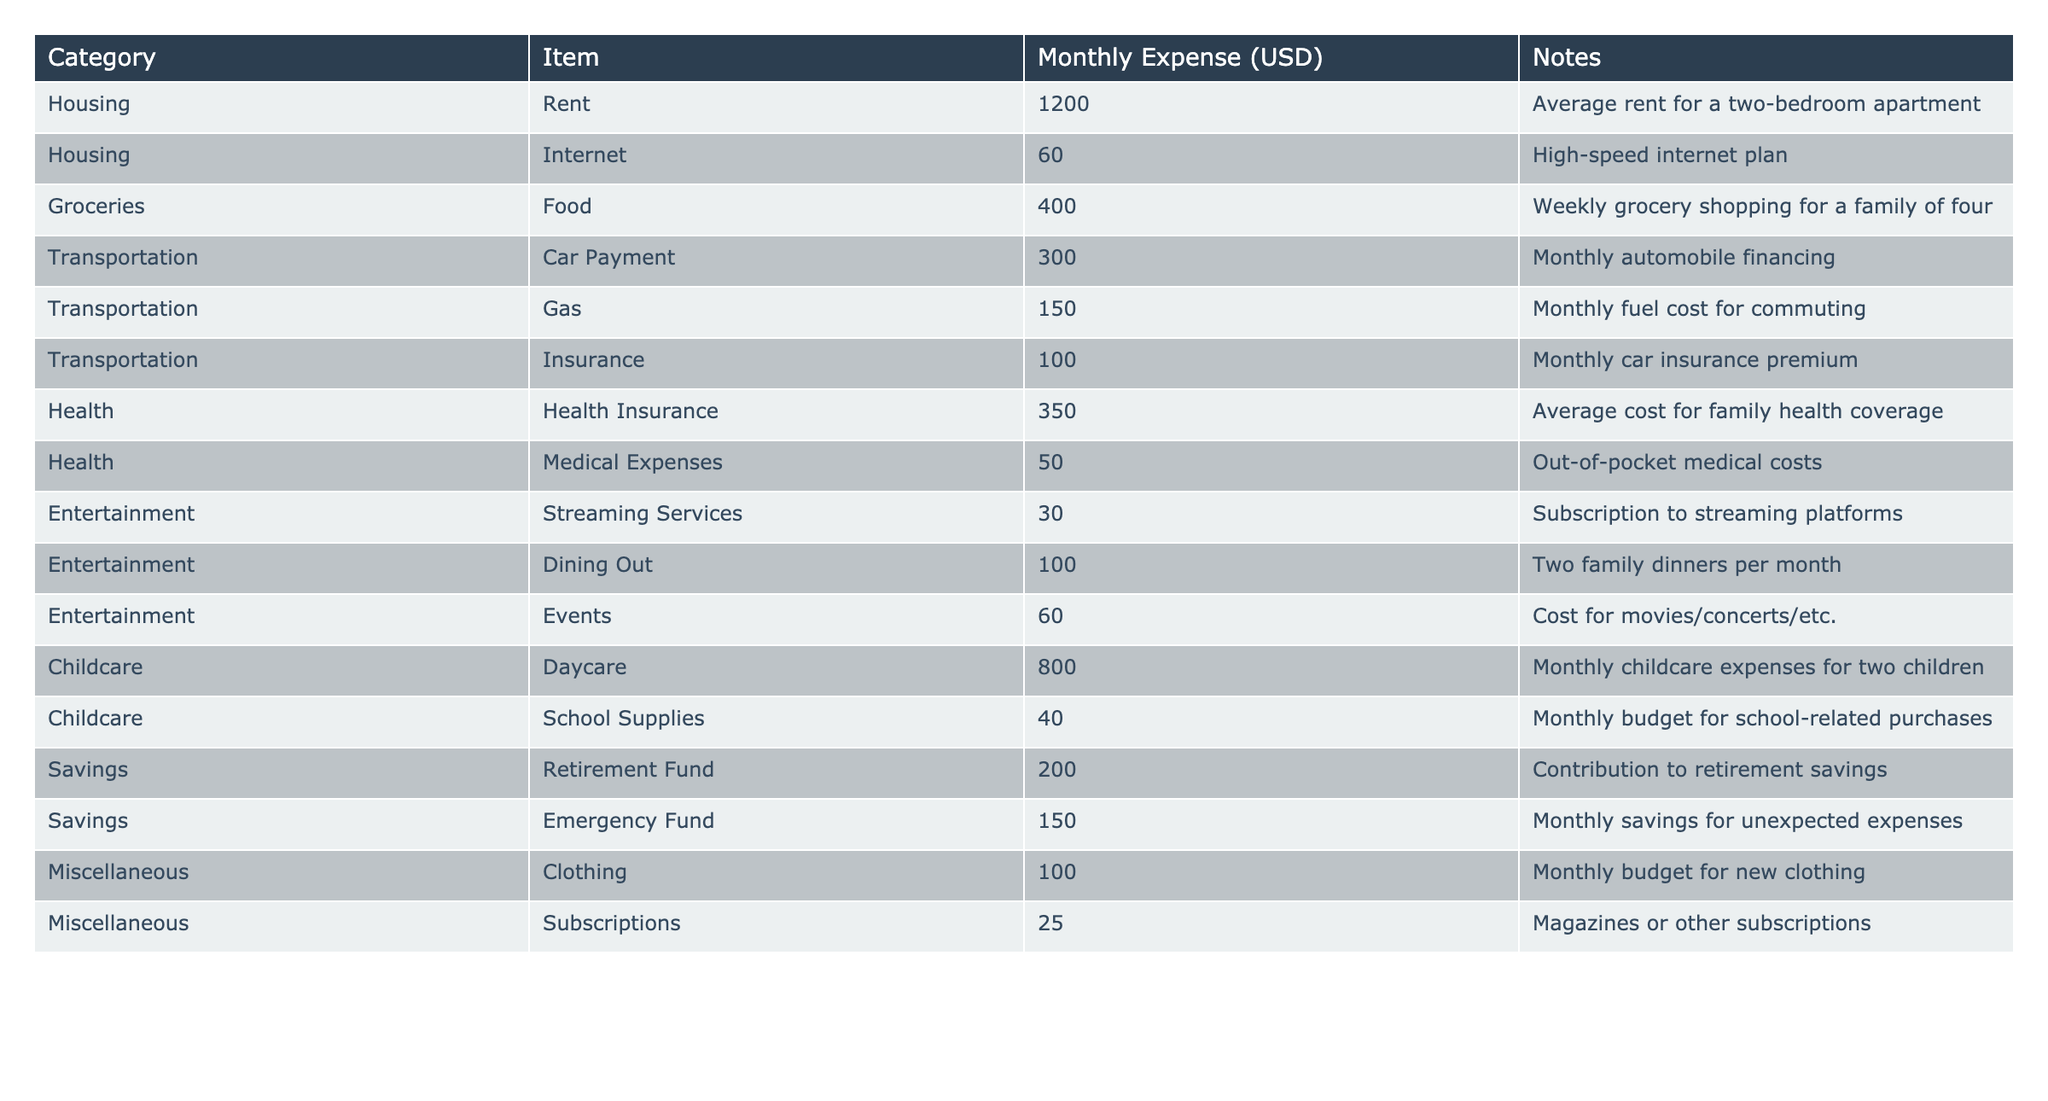What is the total monthly expense for the Housing category? To find the total monthly expense for the Housing category, we sum the expenses for Rent ($1200) and Internet ($60). Thus, $1200 + $60 = $1260.
Answer: 1260 What is the monthly expense for Groceries? The monthly expense for Groceries is listed as $400.
Answer: 400 How much is spent on Childcare items in total? For Childcare, we sum the expenses for Daycare ($800) and School Supplies ($40). Thus, $800 + $40 = $840.
Answer: 840 Is the monthly expense for Health Insurance higher than for Car Insurance? Health Insurance costs $350 and Car Insurance costs $100. Since $350 is greater than $100, the statement is true.
Answer: Yes What is the average monthly expense for the Entertainment category? The expenses in the Entertainment category include Streaming Services ($30), Dining Out ($100), and Events ($60). We sum these: $30 + $100 + $60 = $190, then divide by 3 (the number of items): $190 / 3 ≈ $63.33.
Answer: 63.33 Which category has the highest single monthly expense? The highest single expense in the table is for Childcare (Daycare) at $800.
Answer: Childcare What percentage of total monthly expenses is spent on Savings? First, calculate total monthly expenses: $1200 (Housing) + $60 + $400 (Groceries) + $300 + $150 + $100 (Transportation) + $350 + $50 (Health) + $30 + $100 + $60 (Entertainment) + $800 + $40 (Childcare) + $200 + $150 (Savings) + $100 + $25 (Miscellaneous) = $3145. Then, Savings expenses sum to $200 + $150 = $350, which is ($350 / $3145) * 100 ≈ 11.14%.
Answer: 11.14% If a family decides to cut dining out expenses in half, what will their new Entertainment expense be? Currently, Dining Out costs $100. If they cut this in half, the new cost will be $100 / 2 = $50. Adding to the existing expenses in Entertainment: $30 (Streaming Services) + $50 (new Dining Out) + $60 (Events) = $140.
Answer: 140 What is the difference in monthly expenses between Transportation and Savings? Transportation expenses total $300 (Car Payment) + $150 (Gas) + $100 (Insurance) = $550. Savings expenses total $200 (Retirement Fund) + $150 (Emergency Fund) = $350. The difference is $550 - $350 = $200.
Answer: 200 Is the total expense for Miscellaneous less than the total expense for Transportation? Miscellaneous expenses total $100 (Clothing) + $25 (Subscriptions) = $125. Transportation expenses total $550. Since $125 is less than $550, the statement is true.
Answer: Yes 